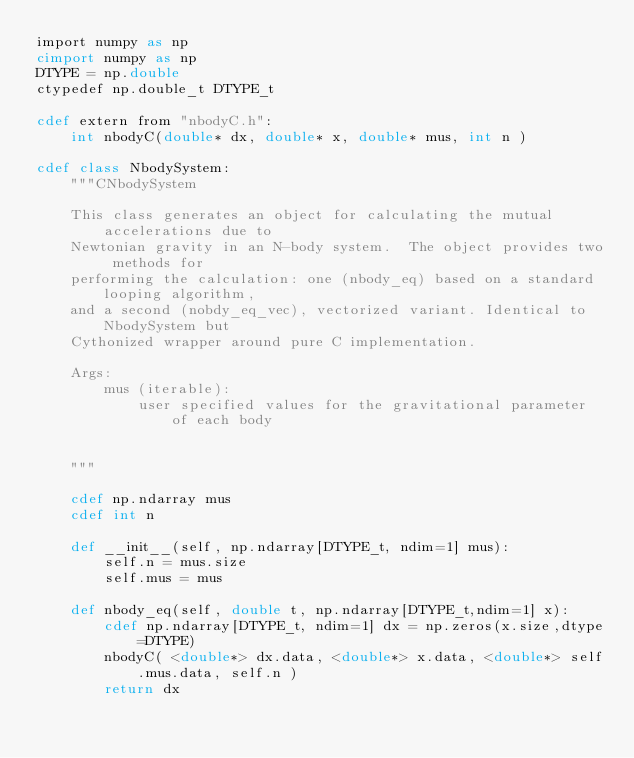Convert code to text. <code><loc_0><loc_0><loc_500><loc_500><_Cython_>import numpy as np
cimport numpy as np
DTYPE = np.double
ctypedef np.double_t DTYPE_t

cdef extern from "nbodyC.h":
    int nbodyC(double* dx, double* x, double* mus, int n )

cdef class NbodySystem:
    """CNbodySystem
    
    This class generates an object for calculating the mutual accelerations due to
    Newtonian gravity in an N-body system.  The object provides two methods for 
    performing the calculation: one (nbody_eq) based on a standard looping algorithm, 
    and a second (nobdy_eq_vec), vectorized variant. Identical to NbodySystem but 
    Cythonized wrapper around pure C implementation.

    Args:         
        mus (iterable):
            user specified values for the gravitational parameter of each body

    
    """

    cdef np.ndarray mus
    cdef int n

    def __init__(self, np.ndarray[DTYPE_t, ndim=1] mus):
        self.n = mus.size
        self.mus = mus

    def nbody_eq(self, double t, np.ndarray[DTYPE_t,ndim=1] x):
        cdef np.ndarray[DTYPE_t, ndim=1] dx = np.zeros(x.size,dtype=DTYPE)
        nbodyC( <double*> dx.data, <double*> x.data, <double*> self.mus.data, self.n )
        return dx
</code> 